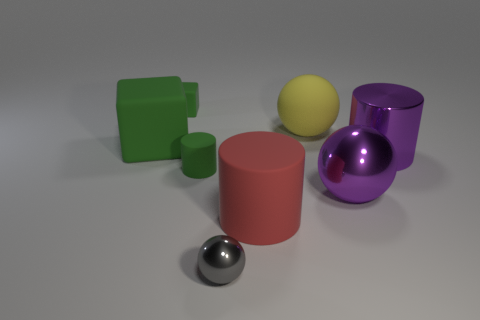Is there any other thing that is the same color as the small cylinder? Yes, there appears to be a larger cylinder in the center of the image that shares the same pink hue as the smaller cylinder to its left. 